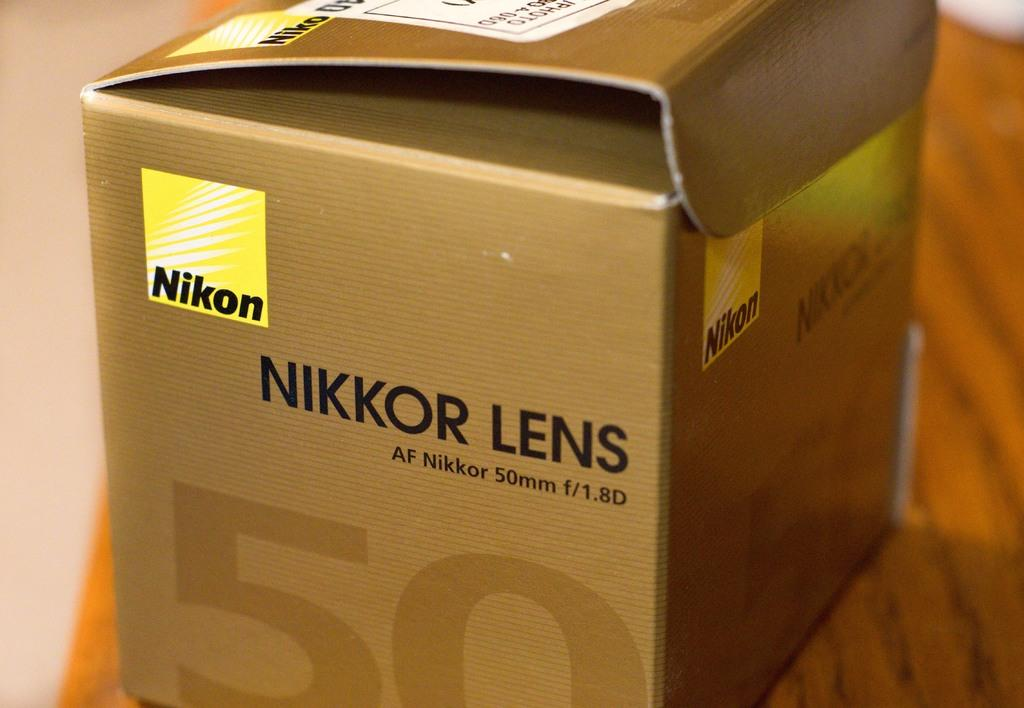<image>
Describe the image concisely. A box of Nikon Nikkor Lens on a wooden surface. 